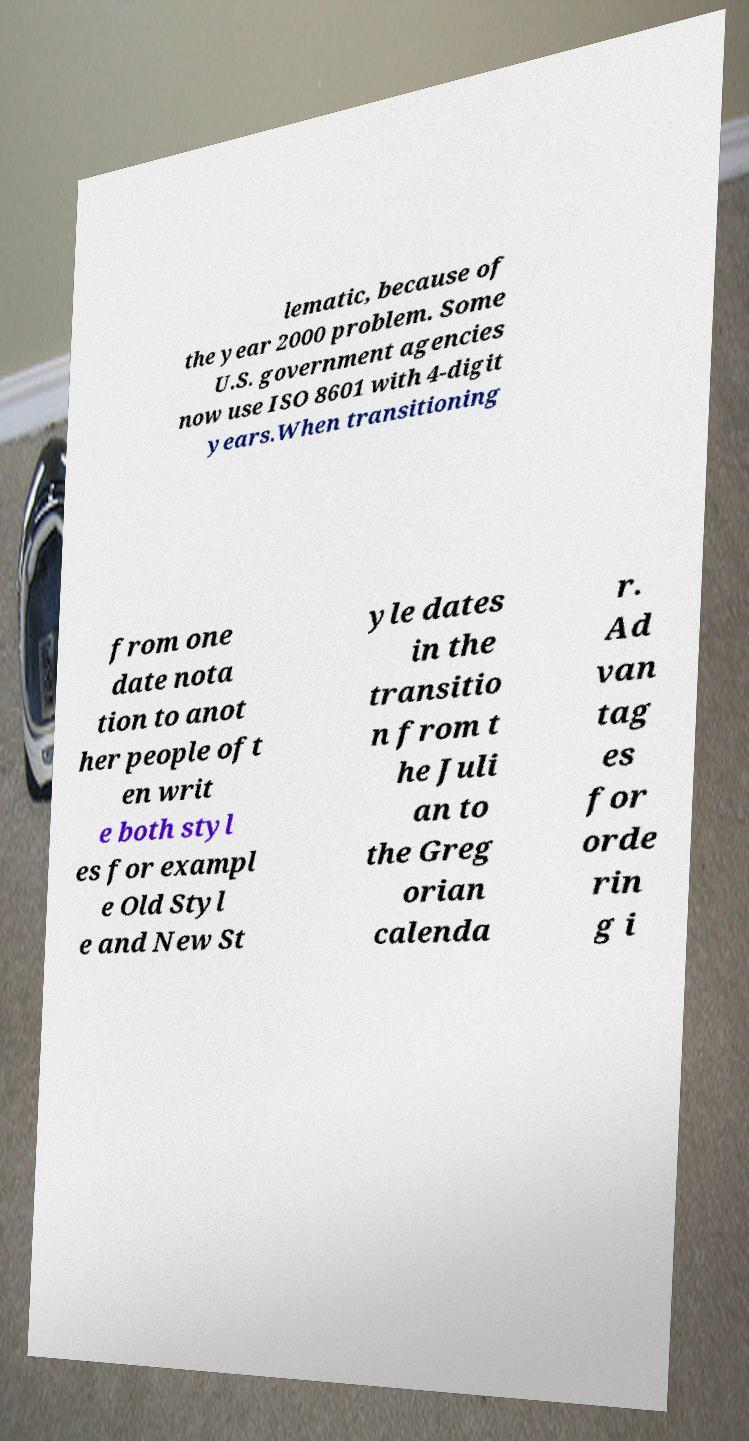What messages or text are displayed in this image? I need them in a readable, typed format. lematic, because of the year 2000 problem. Some U.S. government agencies now use ISO 8601 with 4-digit years.When transitioning from one date nota tion to anot her people oft en writ e both styl es for exampl e Old Styl e and New St yle dates in the transitio n from t he Juli an to the Greg orian calenda r. Ad van tag es for orde rin g i 